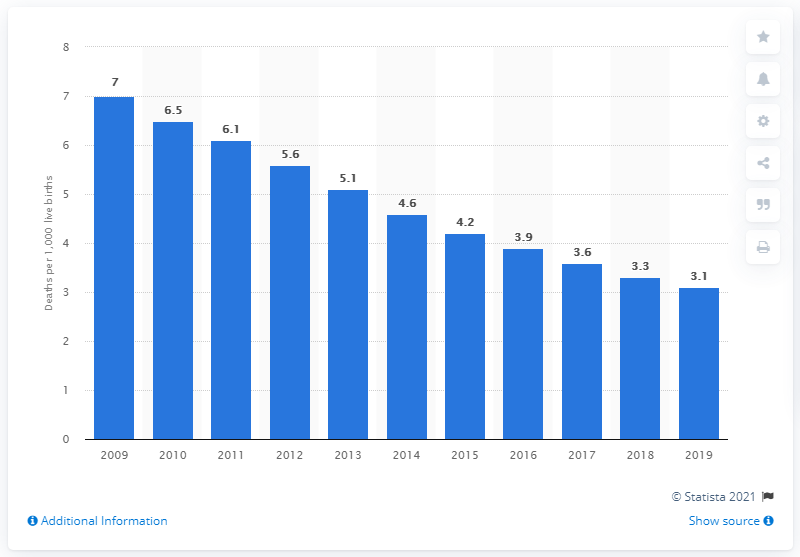Draw attention to some important aspects in this diagram. The infant mortality rate in Latvia in 2019 was 3.1 per 1,000 live births, according to recent data. 